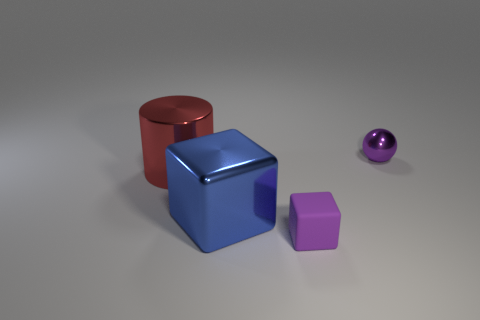Is the color of the small rubber thing the same as the small ball?
Your answer should be compact. Yes. There is a thing that is both on the right side of the large cube and in front of the large red metallic object; what color is it?
Offer a terse response. Purple. The small matte object that is the same color as the tiny shiny object is what shape?
Give a very brief answer. Cube. There is a metallic object behind the big cylinder that is on the left side of the purple rubber thing; what is its size?
Ensure brevity in your answer.  Small. What number of blocks are large blue things or small objects?
Your response must be concise. 2. What is the color of the cube that is the same size as the cylinder?
Keep it short and to the point. Blue. There is a large thing on the left side of the big thing that is on the right side of the red shiny cylinder; what is its shape?
Your answer should be very brief. Cylinder. There is a purple object that is behind the purple block; does it have the same size as the big red object?
Provide a succinct answer. No. What number of other things are there of the same material as the tiny purple cube
Provide a succinct answer. 0. What number of red objects are big shiny balls or shiny things?
Offer a very short reply. 1. 